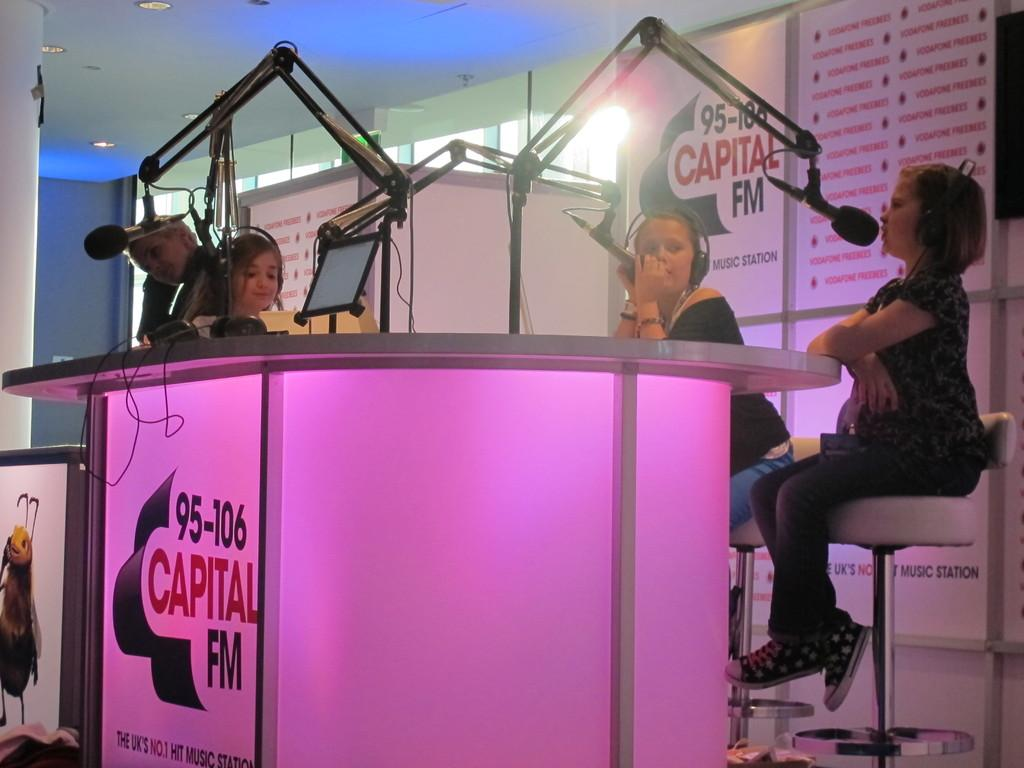How many girls are in the image? There are 3 girls in the image. What are the girls doing in the image? The girls are sitting in chairs and talking into microphones. What can be seen in the background of the image? There are hoardings, lights, a table, and a screen in the background of the image. What type of tooth is visible in the image? There is no tooth present in the image. Is there a sink in the image? No, there is no sink in the image. 